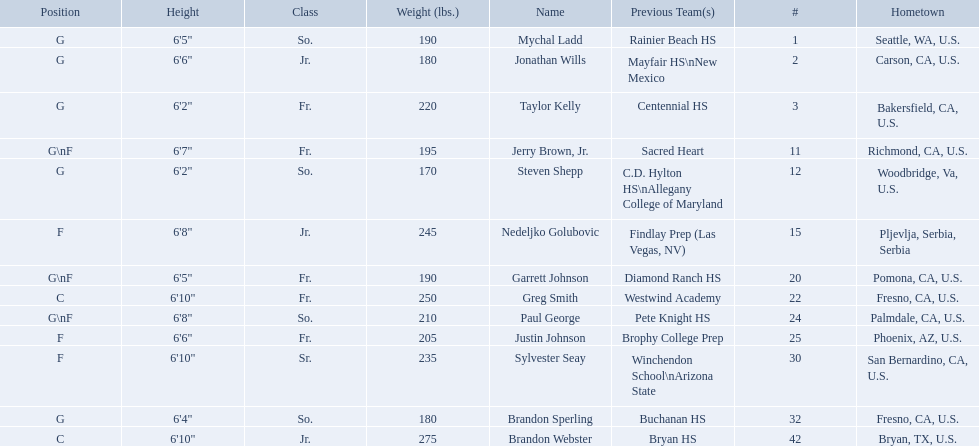Who are all of the players? Mychal Ladd, Jonathan Wills, Taylor Kelly, Jerry Brown, Jr., Steven Shepp, Nedeljko Golubovic, Garrett Johnson, Greg Smith, Paul George, Justin Johnson, Sylvester Seay, Brandon Sperling, Brandon Webster. What are their heights? 6'5", 6'6", 6'2", 6'7", 6'2", 6'8", 6'5", 6'10", 6'8", 6'6", 6'10", 6'4", 6'10". Along with taylor kelly, which other player is shorter than 6'3? Steven Shepp. Which players are forwards? Nedeljko Golubovic, Paul George, Justin Johnson, Sylvester Seay. What are the heights of these players? Nedeljko Golubovic, 6'8", Paul George, 6'8", Justin Johnson, 6'6", Sylvester Seay, 6'10". Of these players, who is the shortest? Justin Johnson. 